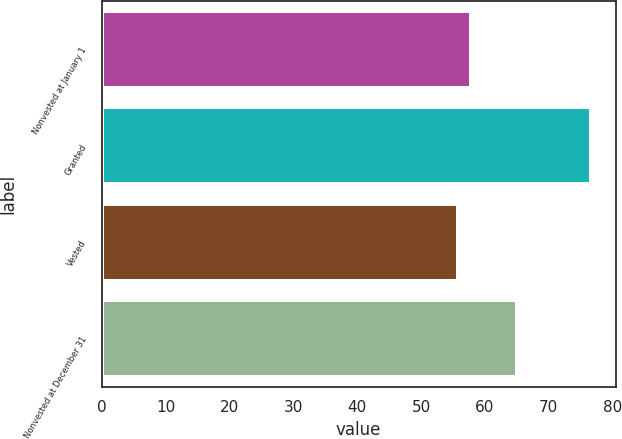Convert chart to OTSL. <chart><loc_0><loc_0><loc_500><loc_500><bar_chart><fcel>Nonvested at January 1<fcel>Granted<fcel>Vested<fcel>Nonvested at December 31<nl><fcel>57.8<fcel>76.61<fcel>55.71<fcel>65.04<nl></chart> 